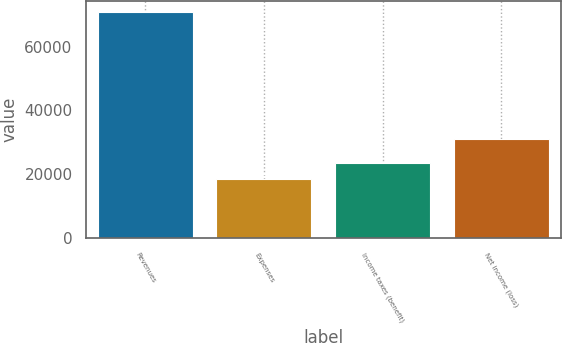Convert chart to OTSL. <chart><loc_0><loc_0><loc_500><loc_500><bar_chart><fcel>Revenues<fcel>Expenses<fcel>Income taxes (benefit)<fcel>Net income (loss)<nl><fcel>70698<fcel>18445<fcel>23670.3<fcel>30991<nl></chart> 